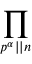Convert formula to latex. <formula><loc_0><loc_0><loc_500><loc_500>\prod _ { p ^ { \alpha } | | n }</formula> 